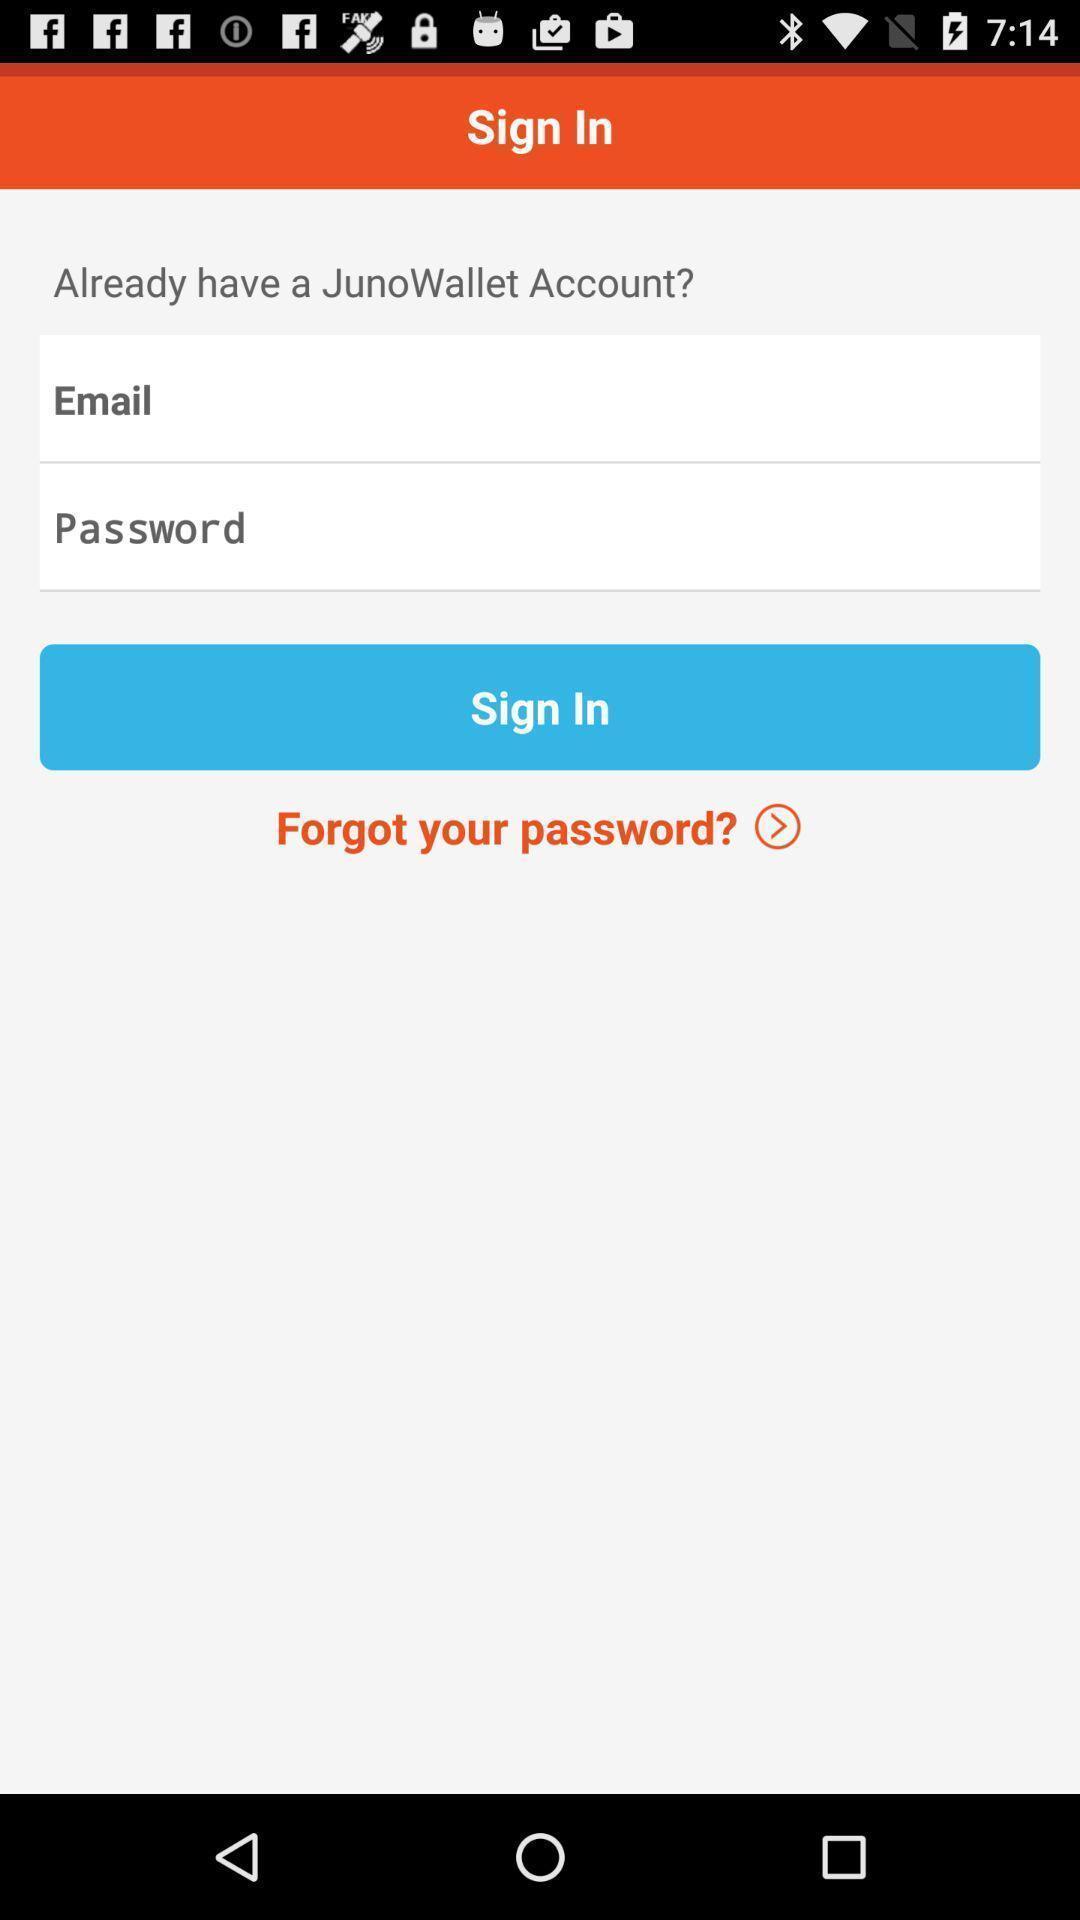Tell me about the visual elements in this screen capture. Sign in page for the application with entry details. 